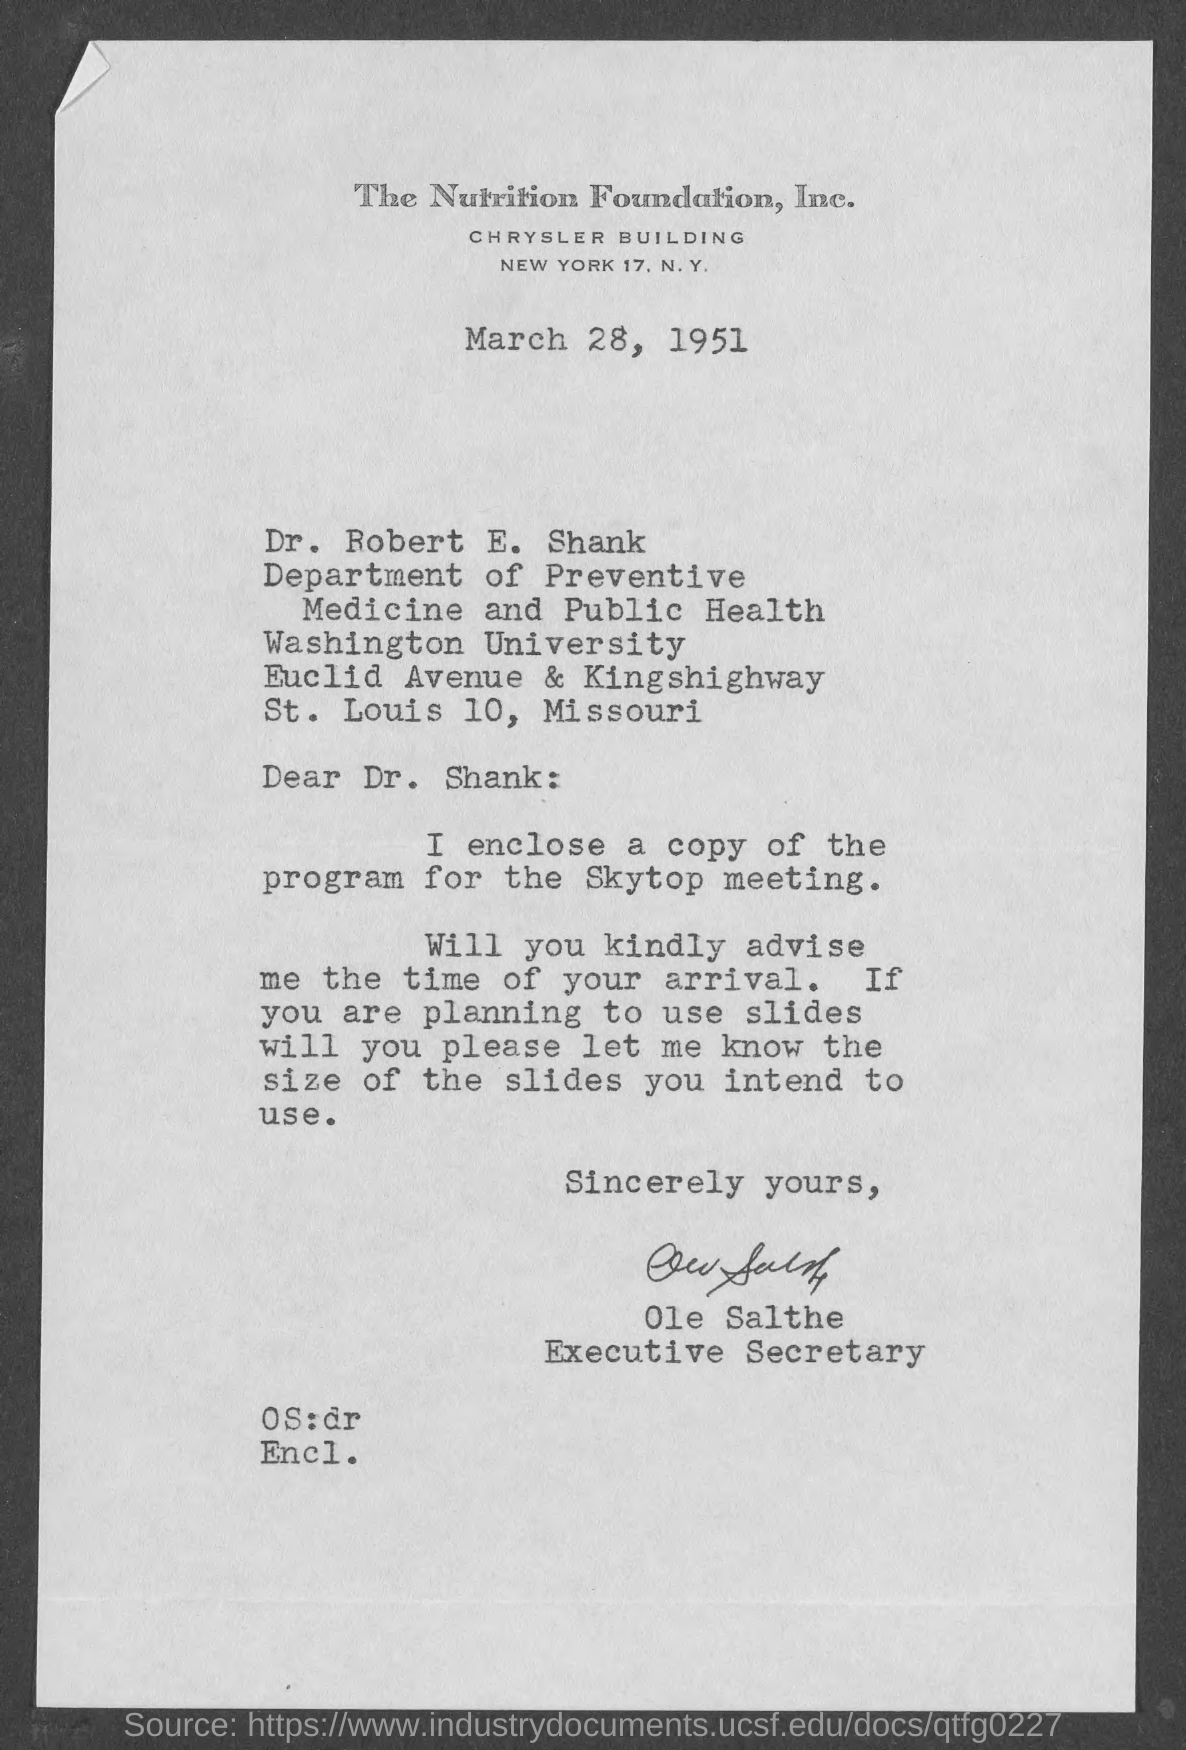What is the date on the document?
Provide a succinct answer. March 28, 1951. To Whom is this letter addressed to?
Keep it short and to the point. Dr. Robert E. Shank. What is the copy enclosed?
Make the answer very short. Program for skytop meeting. Who is this letter from?
Offer a terse response. Executive Secretary. 